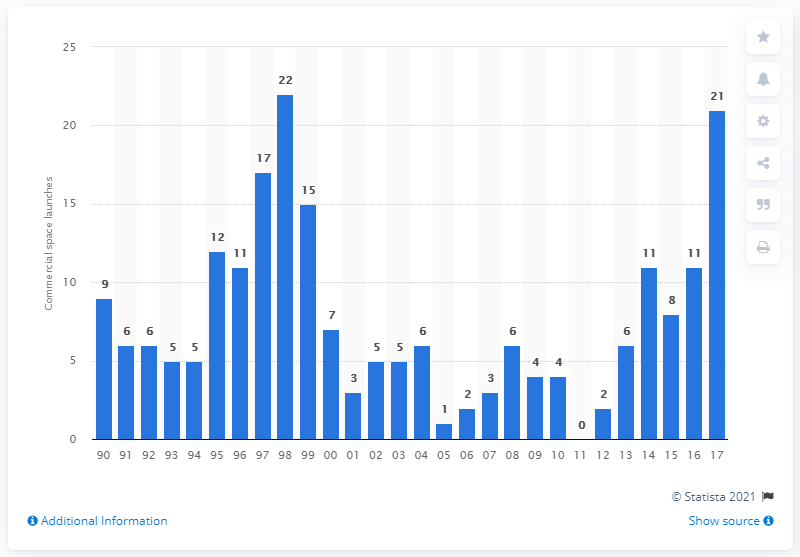Point out several critical features in this image. In 2017, the United States conducted 21 commercial space launches. 